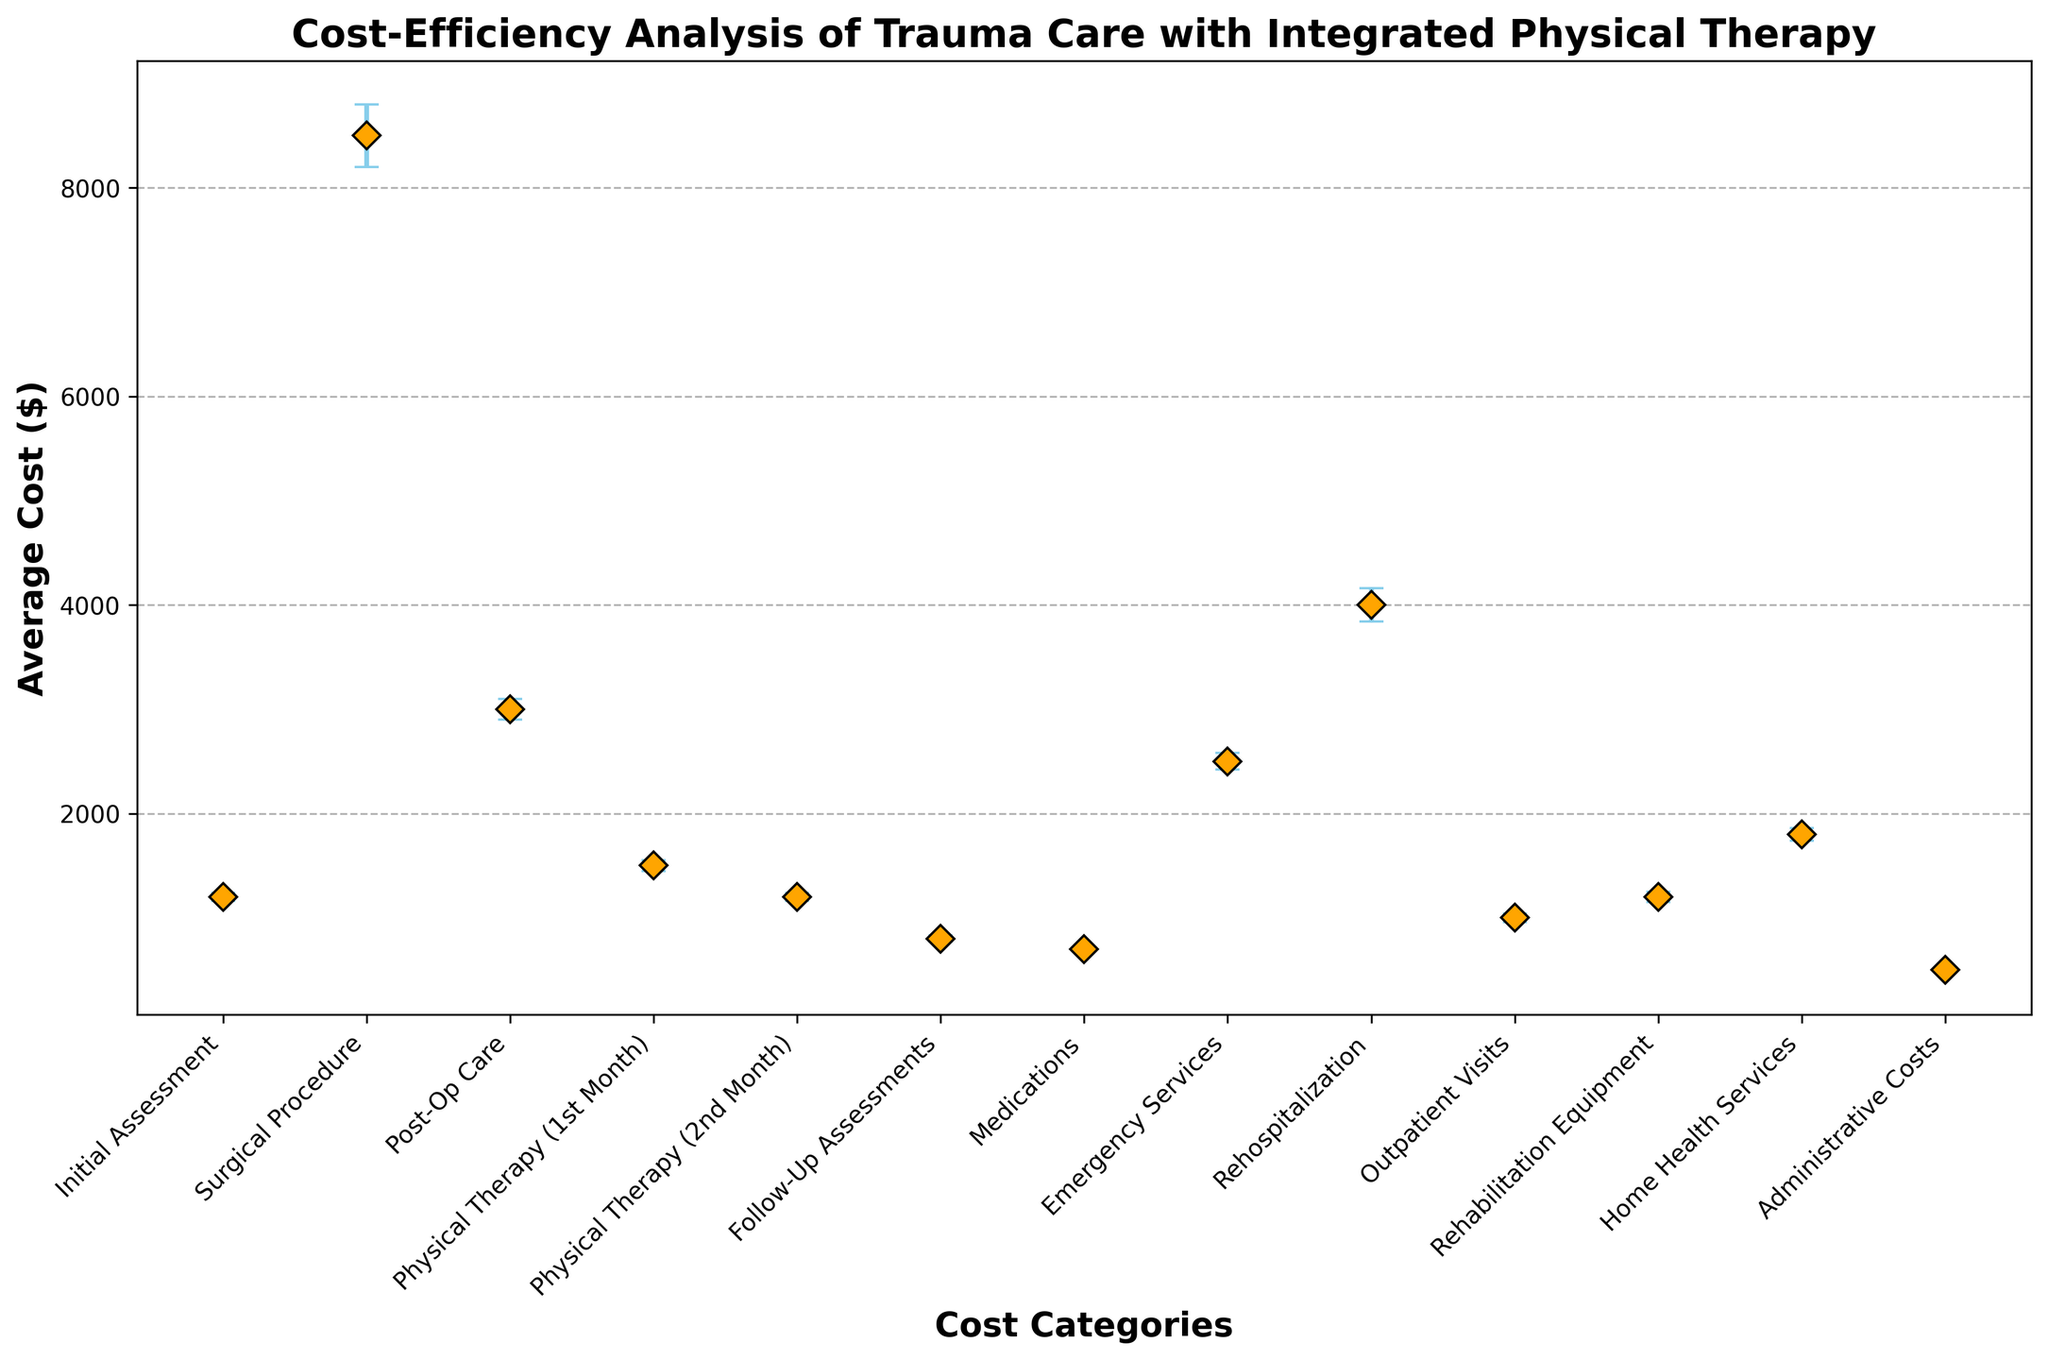Which cost category has the highest average cost? To find the cost category with the highest average cost, we examine the figure for the tallest marker. The 'Surgical Procedure' category stands out with the highest average cost of $8500.
Answer: Surgical Procedure Which cost category has the lowest average cost? We look for the shortest marker in the plot. The 'Administrative Costs' category is the lowest, with an average cost of $500.
Answer: Administrative Costs What is the total average cost for the first two months of physical therapy? Add the average cost of 'Physical Therapy (1st Month)' which is $1500 and 'Physical Therapy (2nd Month)' which is $1200. $1500 + $1200 = $2700.
Answer: $2700 Which two categories have the largest error margins? We review the error bars and identify the two longest ones. 'Surgical Procedure' and 'Rehospitalization' have the largest error margins of $300 and $160, respectively.
Answer: Surgical Procedure and Rehospitalization Compare the average cost of 'Post-Op Care' and 'Initial Assessment'. Which one is higher and by how much? 'Post-Op Care' has an average cost of $3000, while 'Initial Assessment' is $1200. The difference is $3000 - $1200 = $1800, making 'Post-Op Care' higher by $1800.
Answer: Post-Op Care by $1800 What is the average cost and error margin for 'Medications'? Looking at the 'Medications' category, the average cost is $700 and the error margin is $20.
Answer: $700, $20 What is the combined average cost of 'Emergency Services' and 'Home Health Services'? Add the average cost of 'Emergency Services' which is $2500 and 'Home Health Services' at $1800. $2500 + $1800 = $4300.
Answer: $4300 Which category has the second-lowest standard deviation, and what is its value? After 'Administrative Costs' with a standard deviation of $50, the second-lowest is 'Medications' with a standard deviation of $100.
Answer: Medications, $100 How much higher is the average cost of 'Rehospitalization' compared to 'Post-Op Care'? 'Rehospitalization' has an average cost of $4000, whereas 'Post-Op Care' is $3000. The difference is $4000 - $3000 = $1000.
Answer: $1000 What is the total average cost for 'Initial Assessment' and 'Follow-Up Assessments'? Add the average cost of 'Initial Assessment' which is $1200 and 'Follow-Up Assessments' at $800. $1200 + $800 = $2000.
Answer: $2000 